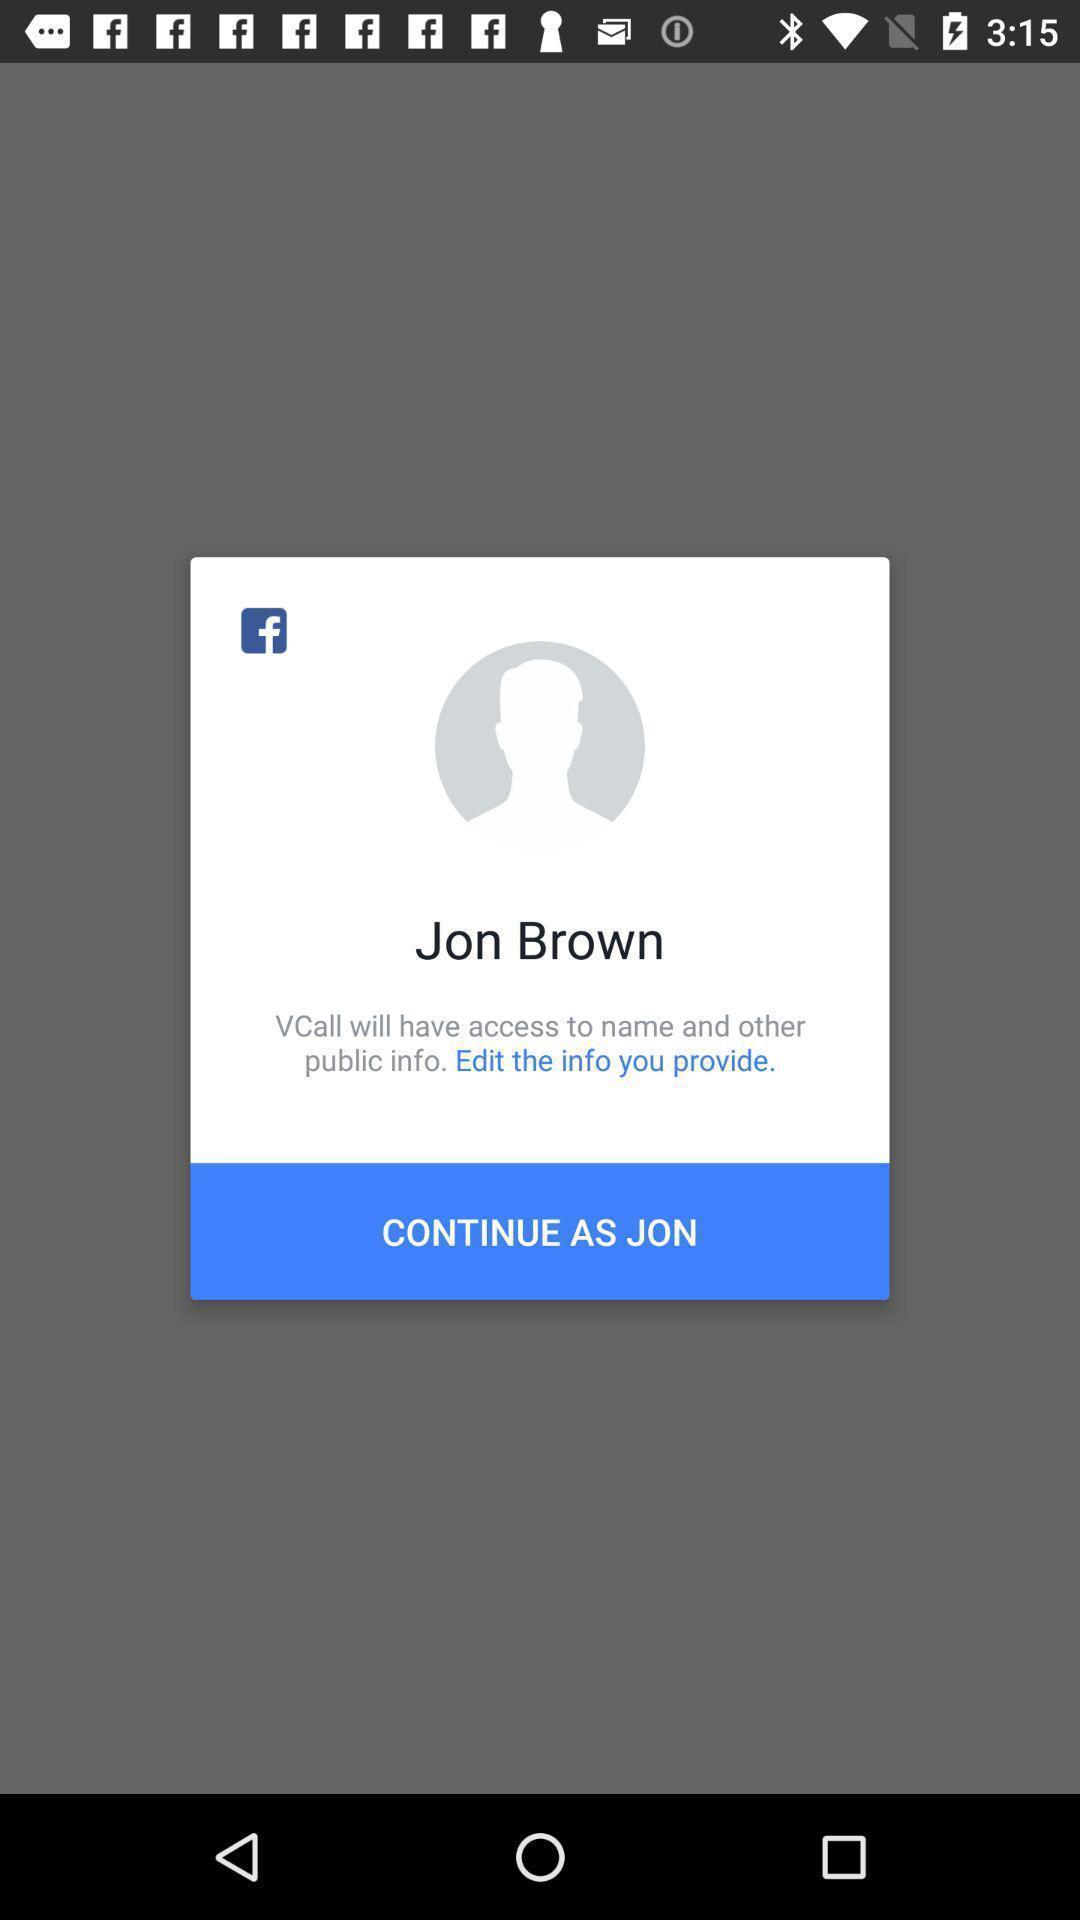Describe the visual elements of this screenshot. Pop-up window showing a profile to continue with the app. 